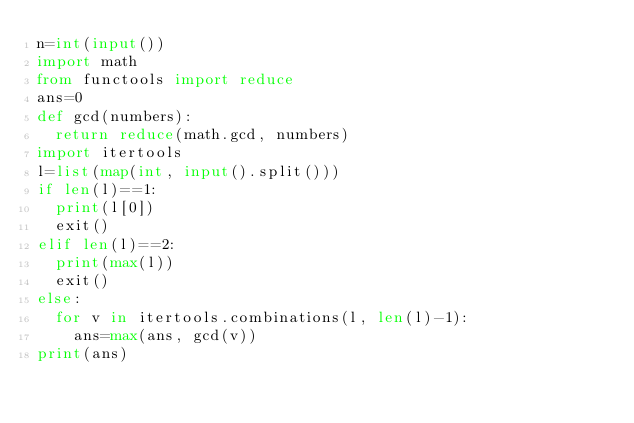<code> <loc_0><loc_0><loc_500><loc_500><_Python_>n=int(input())
import math
from functools import reduce
ans=0
def gcd(numbers):
  return reduce(math.gcd, numbers)
import itertools
l=list(map(int, input().split()))
if len(l)==1:
  print(l[0])
  exit()
elif len(l)==2:
  print(max(l))
  exit()
else: 
  for v in itertools.combinations(l, len(l)-1):
    ans=max(ans, gcd(v))
print(ans)

</code> 